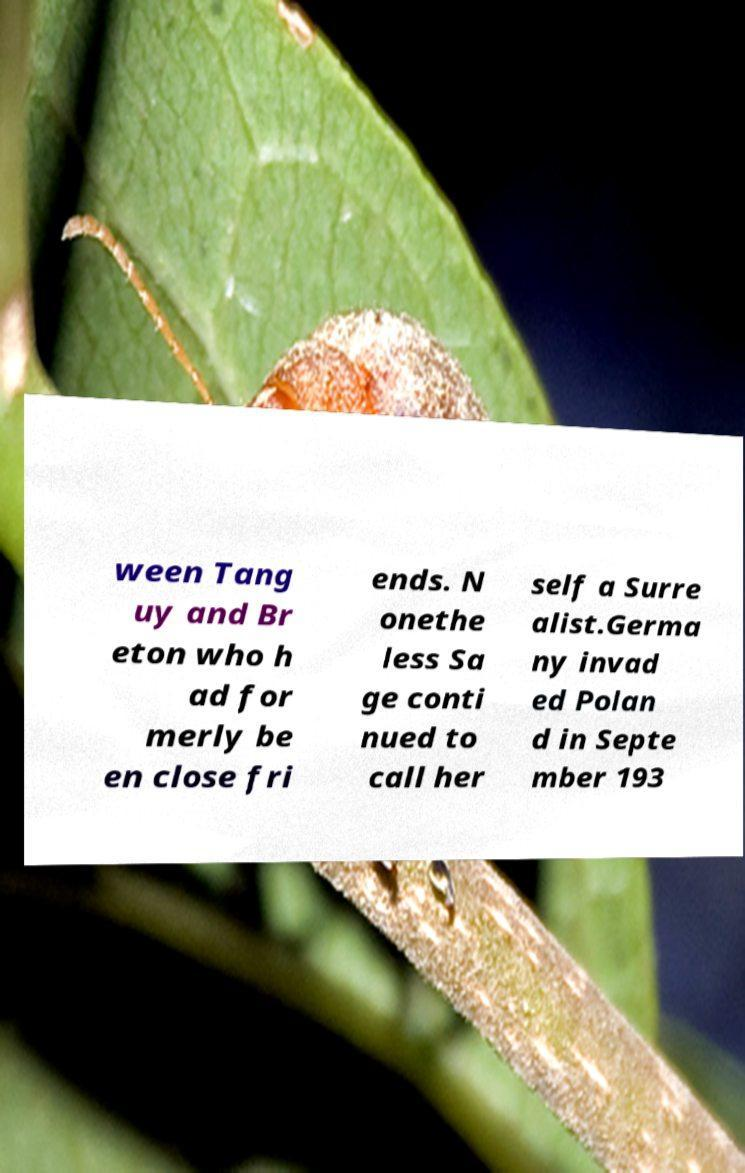For documentation purposes, I need the text within this image transcribed. Could you provide that? ween Tang uy and Br eton who h ad for merly be en close fri ends. N onethe less Sa ge conti nued to call her self a Surre alist.Germa ny invad ed Polan d in Septe mber 193 